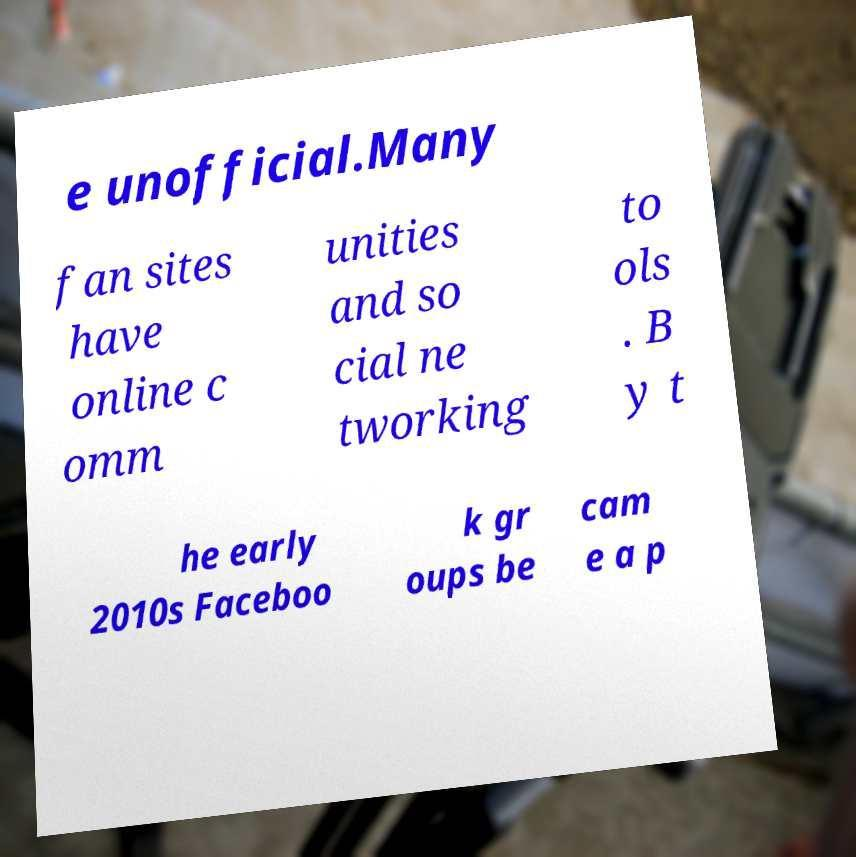Please identify and transcribe the text found in this image. e unofficial.Many fan sites have online c omm unities and so cial ne tworking to ols . B y t he early 2010s Faceboo k gr oups be cam e a p 